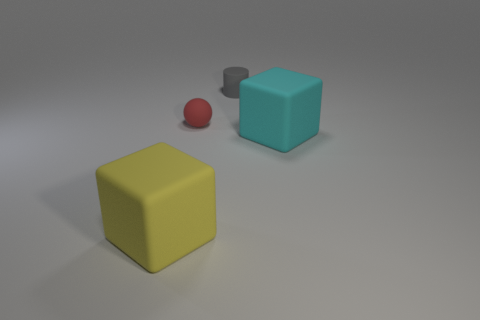There is a thing behind the small red matte thing; how big is it?
Your answer should be compact. Small. How many other small red spheres are the same material as the tiny red sphere?
Ensure brevity in your answer.  0. Is the material of the large cube in front of the big cyan thing the same as the big block right of the small rubber ball?
Your answer should be compact. Yes. What number of cyan matte blocks are on the right side of the big matte block that is on the left side of the rubber block right of the cylinder?
Your answer should be very brief. 1. There is a big thing behind the thing in front of the cyan thing; what is its color?
Keep it short and to the point. Cyan. Are there any large blue shiny cylinders?
Offer a terse response. No. There is a rubber object that is in front of the tiny rubber ball and right of the sphere; what is its color?
Give a very brief answer. Cyan. There is a rubber block that is behind the large yellow rubber block; is its size the same as the gray cylinder on the left side of the big cyan rubber cube?
Offer a very short reply. No. How many other things are there of the same size as the red matte ball?
Offer a very short reply. 1. There is a big thing to the right of the gray cylinder; how many cubes are in front of it?
Provide a short and direct response. 1. 